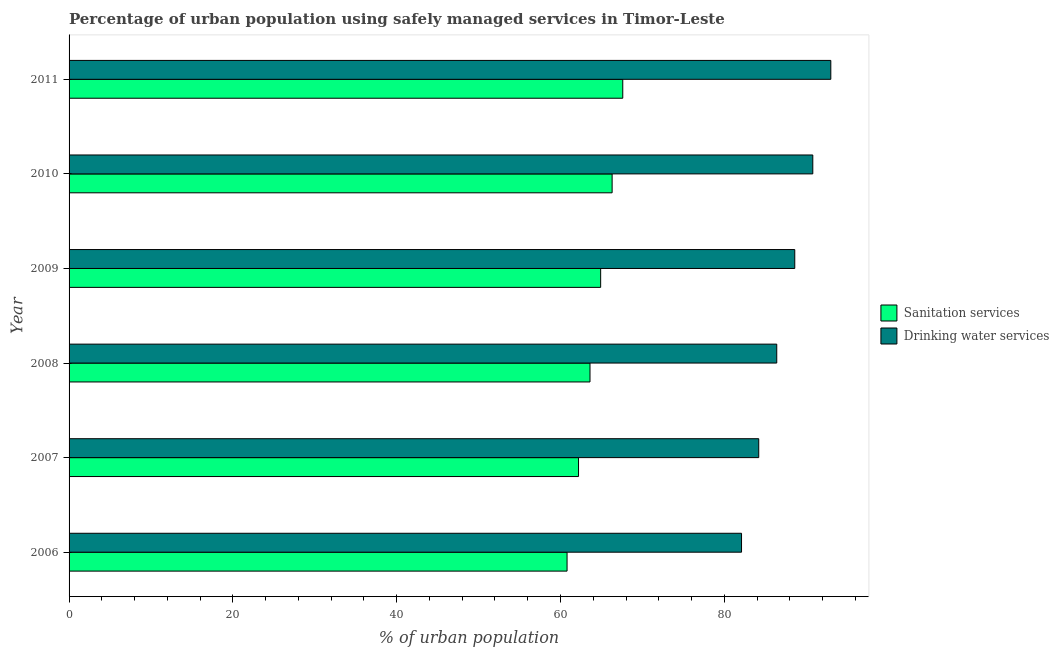How many different coloured bars are there?
Your answer should be compact. 2. Are the number of bars per tick equal to the number of legend labels?
Keep it short and to the point. Yes. How many bars are there on the 4th tick from the top?
Ensure brevity in your answer.  2. How many bars are there on the 6th tick from the bottom?
Keep it short and to the point. 2. What is the label of the 3rd group of bars from the top?
Keep it short and to the point. 2009. What is the percentage of urban population who used sanitation services in 2010?
Keep it short and to the point. 66.3. Across all years, what is the maximum percentage of urban population who used drinking water services?
Your answer should be compact. 93. Across all years, what is the minimum percentage of urban population who used sanitation services?
Your answer should be compact. 60.8. In which year was the percentage of urban population who used sanitation services maximum?
Your answer should be very brief. 2011. What is the total percentage of urban population who used sanitation services in the graph?
Offer a terse response. 385.4. What is the difference between the percentage of urban population who used sanitation services in 2009 and that in 2010?
Keep it short and to the point. -1.4. What is the difference between the percentage of urban population who used drinking water services in 2009 and the percentage of urban population who used sanitation services in 2007?
Your answer should be compact. 26.4. What is the average percentage of urban population who used sanitation services per year?
Offer a terse response. 64.23. In the year 2009, what is the difference between the percentage of urban population who used drinking water services and percentage of urban population who used sanitation services?
Provide a short and direct response. 23.7. In how many years, is the percentage of urban population who used drinking water services greater than 64 %?
Your answer should be compact. 6. What is the ratio of the percentage of urban population who used sanitation services in 2006 to that in 2010?
Your answer should be compact. 0.92. Is the percentage of urban population who used sanitation services in 2007 less than that in 2009?
Keep it short and to the point. Yes. What is the difference between the highest and the lowest percentage of urban population who used drinking water services?
Your response must be concise. 10.9. What does the 2nd bar from the top in 2009 represents?
Make the answer very short. Sanitation services. What does the 1st bar from the bottom in 2011 represents?
Keep it short and to the point. Sanitation services. How many bars are there?
Give a very brief answer. 12. Does the graph contain any zero values?
Your response must be concise. No. What is the title of the graph?
Make the answer very short. Percentage of urban population using safely managed services in Timor-Leste. What is the label or title of the X-axis?
Your response must be concise. % of urban population. What is the % of urban population of Sanitation services in 2006?
Keep it short and to the point. 60.8. What is the % of urban population in Drinking water services in 2006?
Keep it short and to the point. 82.1. What is the % of urban population of Sanitation services in 2007?
Give a very brief answer. 62.2. What is the % of urban population of Drinking water services in 2007?
Your answer should be very brief. 84.2. What is the % of urban population of Sanitation services in 2008?
Offer a terse response. 63.6. What is the % of urban population in Drinking water services in 2008?
Your response must be concise. 86.4. What is the % of urban population in Sanitation services in 2009?
Your answer should be very brief. 64.9. What is the % of urban population in Drinking water services in 2009?
Ensure brevity in your answer.  88.6. What is the % of urban population in Sanitation services in 2010?
Your answer should be compact. 66.3. What is the % of urban population of Drinking water services in 2010?
Offer a terse response. 90.8. What is the % of urban population of Sanitation services in 2011?
Ensure brevity in your answer.  67.6. What is the % of urban population in Drinking water services in 2011?
Keep it short and to the point. 93. Across all years, what is the maximum % of urban population in Sanitation services?
Your answer should be compact. 67.6. Across all years, what is the maximum % of urban population of Drinking water services?
Keep it short and to the point. 93. Across all years, what is the minimum % of urban population of Sanitation services?
Offer a terse response. 60.8. Across all years, what is the minimum % of urban population of Drinking water services?
Your answer should be compact. 82.1. What is the total % of urban population in Sanitation services in the graph?
Provide a short and direct response. 385.4. What is the total % of urban population in Drinking water services in the graph?
Your response must be concise. 525.1. What is the difference between the % of urban population of Drinking water services in 2006 and that in 2008?
Your response must be concise. -4.3. What is the difference between the % of urban population of Sanitation services in 2006 and that in 2009?
Make the answer very short. -4.1. What is the difference between the % of urban population of Drinking water services in 2006 and that in 2009?
Your answer should be compact. -6.5. What is the difference between the % of urban population of Drinking water services in 2006 and that in 2011?
Your answer should be very brief. -10.9. What is the difference between the % of urban population in Drinking water services in 2007 and that in 2008?
Make the answer very short. -2.2. What is the difference between the % of urban population of Sanitation services in 2007 and that in 2009?
Your answer should be very brief. -2.7. What is the difference between the % of urban population of Sanitation services in 2007 and that in 2010?
Keep it short and to the point. -4.1. What is the difference between the % of urban population in Sanitation services in 2007 and that in 2011?
Ensure brevity in your answer.  -5.4. What is the difference between the % of urban population of Drinking water services in 2007 and that in 2011?
Offer a terse response. -8.8. What is the difference between the % of urban population of Sanitation services in 2008 and that in 2009?
Offer a terse response. -1.3. What is the difference between the % of urban population in Drinking water services in 2008 and that in 2009?
Your answer should be very brief. -2.2. What is the difference between the % of urban population in Drinking water services in 2008 and that in 2010?
Offer a very short reply. -4.4. What is the difference between the % of urban population in Drinking water services in 2008 and that in 2011?
Provide a short and direct response. -6.6. What is the difference between the % of urban population in Sanitation services in 2009 and that in 2010?
Ensure brevity in your answer.  -1.4. What is the difference between the % of urban population in Drinking water services in 2009 and that in 2011?
Your answer should be very brief. -4.4. What is the difference between the % of urban population in Sanitation services in 2010 and that in 2011?
Keep it short and to the point. -1.3. What is the difference between the % of urban population of Sanitation services in 2006 and the % of urban population of Drinking water services in 2007?
Make the answer very short. -23.4. What is the difference between the % of urban population in Sanitation services in 2006 and the % of urban population in Drinking water services in 2008?
Make the answer very short. -25.6. What is the difference between the % of urban population of Sanitation services in 2006 and the % of urban population of Drinking water services in 2009?
Provide a succinct answer. -27.8. What is the difference between the % of urban population of Sanitation services in 2006 and the % of urban population of Drinking water services in 2010?
Make the answer very short. -30. What is the difference between the % of urban population of Sanitation services in 2006 and the % of urban population of Drinking water services in 2011?
Give a very brief answer. -32.2. What is the difference between the % of urban population of Sanitation services in 2007 and the % of urban population of Drinking water services in 2008?
Keep it short and to the point. -24.2. What is the difference between the % of urban population of Sanitation services in 2007 and the % of urban population of Drinking water services in 2009?
Your response must be concise. -26.4. What is the difference between the % of urban population of Sanitation services in 2007 and the % of urban population of Drinking water services in 2010?
Keep it short and to the point. -28.6. What is the difference between the % of urban population of Sanitation services in 2007 and the % of urban population of Drinking water services in 2011?
Offer a very short reply. -30.8. What is the difference between the % of urban population of Sanitation services in 2008 and the % of urban population of Drinking water services in 2010?
Ensure brevity in your answer.  -27.2. What is the difference between the % of urban population of Sanitation services in 2008 and the % of urban population of Drinking water services in 2011?
Keep it short and to the point. -29.4. What is the difference between the % of urban population of Sanitation services in 2009 and the % of urban population of Drinking water services in 2010?
Offer a very short reply. -25.9. What is the difference between the % of urban population of Sanitation services in 2009 and the % of urban population of Drinking water services in 2011?
Your response must be concise. -28.1. What is the difference between the % of urban population in Sanitation services in 2010 and the % of urban population in Drinking water services in 2011?
Your answer should be very brief. -26.7. What is the average % of urban population in Sanitation services per year?
Offer a terse response. 64.23. What is the average % of urban population of Drinking water services per year?
Give a very brief answer. 87.52. In the year 2006, what is the difference between the % of urban population in Sanitation services and % of urban population in Drinking water services?
Your response must be concise. -21.3. In the year 2007, what is the difference between the % of urban population in Sanitation services and % of urban population in Drinking water services?
Ensure brevity in your answer.  -22. In the year 2008, what is the difference between the % of urban population in Sanitation services and % of urban population in Drinking water services?
Make the answer very short. -22.8. In the year 2009, what is the difference between the % of urban population of Sanitation services and % of urban population of Drinking water services?
Your answer should be compact. -23.7. In the year 2010, what is the difference between the % of urban population in Sanitation services and % of urban population in Drinking water services?
Offer a very short reply. -24.5. In the year 2011, what is the difference between the % of urban population of Sanitation services and % of urban population of Drinking water services?
Offer a terse response. -25.4. What is the ratio of the % of urban population of Sanitation services in 2006 to that in 2007?
Your answer should be very brief. 0.98. What is the ratio of the % of urban population in Drinking water services in 2006 to that in 2007?
Provide a succinct answer. 0.98. What is the ratio of the % of urban population of Sanitation services in 2006 to that in 2008?
Provide a short and direct response. 0.96. What is the ratio of the % of urban population in Drinking water services in 2006 to that in 2008?
Ensure brevity in your answer.  0.95. What is the ratio of the % of urban population of Sanitation services in 2006 to that in 2009?
Give a very brief answer. 0.94. What is the ratio of the % of urban population in Drinking water services in 2006 to that in 2009?
Your answer should be very brief. 0.93. What is the ratio of the % of urban population of Sanitation services in 2006 to that in 2010?
Offer a very short reply. 0.92. What is the ratio of the % of urban population of Drinking water services in 2006 to that in 2010?
Provide a succinct answer. 0.9. What is the ratio of the % of urban population of Sanitation services in 2006 to that in 2011?
Make the answer very short. 0.9. What is the ratio of the % of urban population of Drinking water services in 2006 to that in 2011?
Your answer should be compact. 0.88. What is the ratio of the % of urban population in Drinking water services in 2007 to that in 2008?
Provide a short and direct response. 0.97. What is the ratio of the % of urban population of Sanitation services in 2007 to that in 2009?
Offer a very short reply. 0.96. What is the ratio of the % of urban population of Drinking water services in 2007 to that in 2009?
Offer a very short reply. 0.95. What is the ratio of the % of urban population of Sanitation services in 2007 to that in 2010?
Your response must be concise. 0.94. What is the ratio of the % of urban population of Drinking water services in 2007 to that in 2010?
Your response must be concise. 0.93. What is the ratio of the % of urban population of Sanitation services in 2007 to that in 2011?
Offer a very short reply. 0.92. What is the ratio of the % of urban population in Drinking water services in 2007 to that in 2011?
Provide a short and direct response. 0.91. What is the ratio of the % of urban population in Sanitation services in 2008 to that in 2009?
Ensure brevity in your answer.  0.98. What is the ratio of the % of urban population in Drinking water services in 2008 to that in 2009?
Your answer should be very brief. 0.98. What is the ratio of the % of urban population of Sanitation services in 2008 to that in 2010?
Your answer should be compact. 0.96. What is the ratio of the % of urban population in Drinking water services in 2008 to that in 2010?
Offer a terse response. 0.95. What is the ratio of the % of urban population of Sanitation services in 2008 to that in 2011?
Offer a terse response. 0.94. What is the ratio of the % of urban population of Drinking water services in 2008 to that in 2011?
Offer a very short reply. 0.93. What is the ratio of the % of urban population of Sanitation services in 2009 to that in 2010?
Ensure brevity in your answer.  0.98. What is the ratio of the % of urban population in Drinking water services in 2009 to that in 2010?
Your answer should be very brief. 0.98. What is the ratio of the % of urban population of Sanitation services in 2009 to that in 2011?
Ensure brevity in your answer.  0.96. What is the ratio of the % of urban population in Drinking water services in 2009 to that in 2011?
Your response must be concise. 0.95. What is the ratio of the % of urban population of Sanitation services in 2010 to that in 2011?
Your answer should be very brief. 0.98. What is the ratio of the % of urban population in Drinking water services in 2010 to that in 2011?
Your answer should be very brief. 0.98. What is the difference between the highest and the lowest % of urban population in Sanitation services?
Offer a very short reply. 6.8. What is the difference between the highest and the lowest % of urban population in Drinking water services?
Keep it short and to the point. 10.9. 